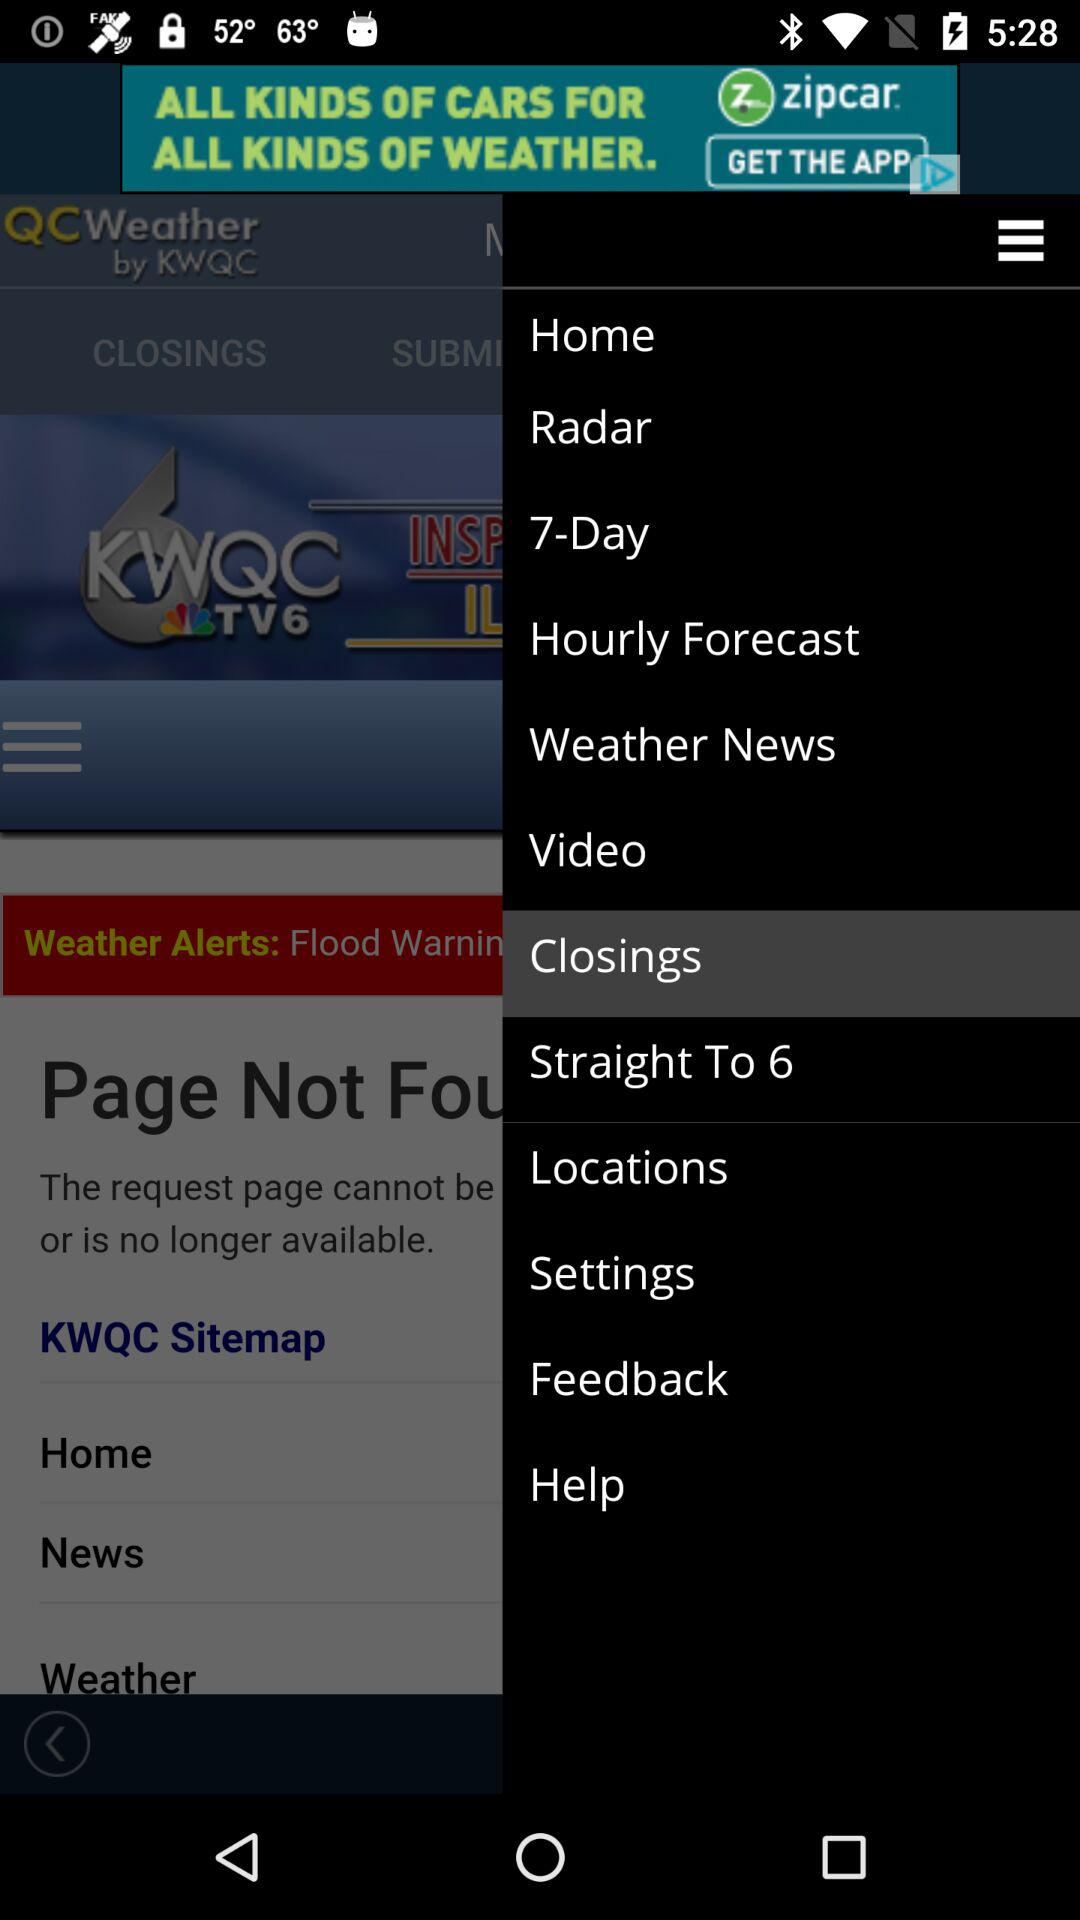What is the name of the application? The names of the applications are "QCWeather" and "zipcar". 